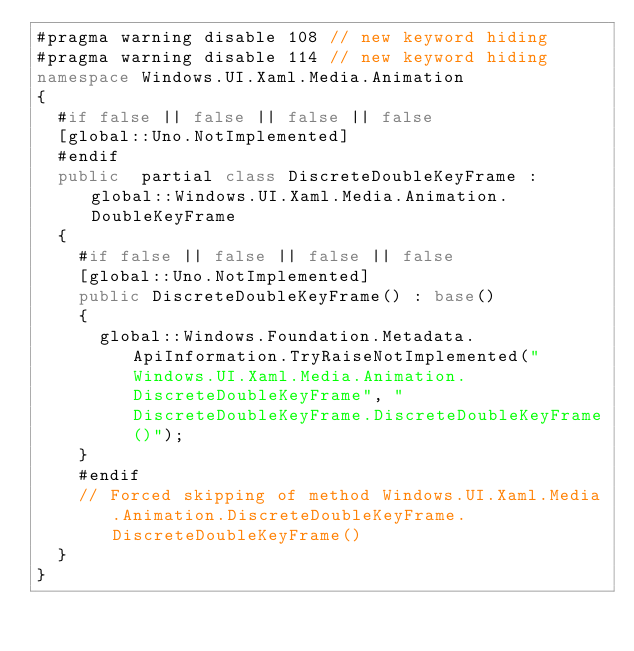<code> <loc_0><loc_0><loc_500><loc_500><_C#_>#pragma warning disable 108 // new keyword hiding
#pragma warning disable 114 // new keyword hiding
namespace Windows.UI.Xaml.Media.Animation
{
	#if false || false || false || false
	[global::Uno.NotImplemented]
	#endif
	public  partial class DiscreteDoubleKeyFrame : global::Windows.UI.Xaml.Media.Animation.DoubleKeyFrame
	{
		#if false || false || false || false
		[global::Uno.NotImplemented]
		public DiscreteDoubleKeyFrame() : base()
		{
			global::Windows.Foundation.Metadata.ApiInformation.TryRaiseNotImplemented("Windows.UI.Xaml.Media.Animation.DiscreteDoubleKeyFrame", "DiscreteDoubleKeyFrame.DiscreteDoubleKeyFrame()");
		}
		#endif
		// Forced skipping of method Windows.UI.Xaml.Media.Animation.DiscreteDoubleKeyFrame.DiscreteDoubleKeyFrame()
	}
}
</code> 